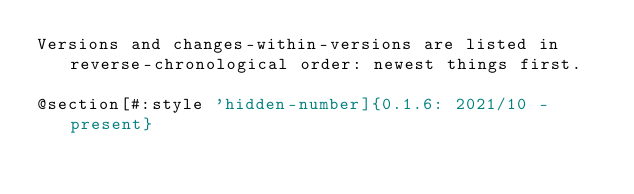<code> <loc_0><loc_0><loc_500><loc_500><_Racket_>Versions and changes-within-versions are listed in reverse-chronological order: newest things first.

@section[#:style 'hidden-number]{0.1.6: 2021/10 - present}
</code> 